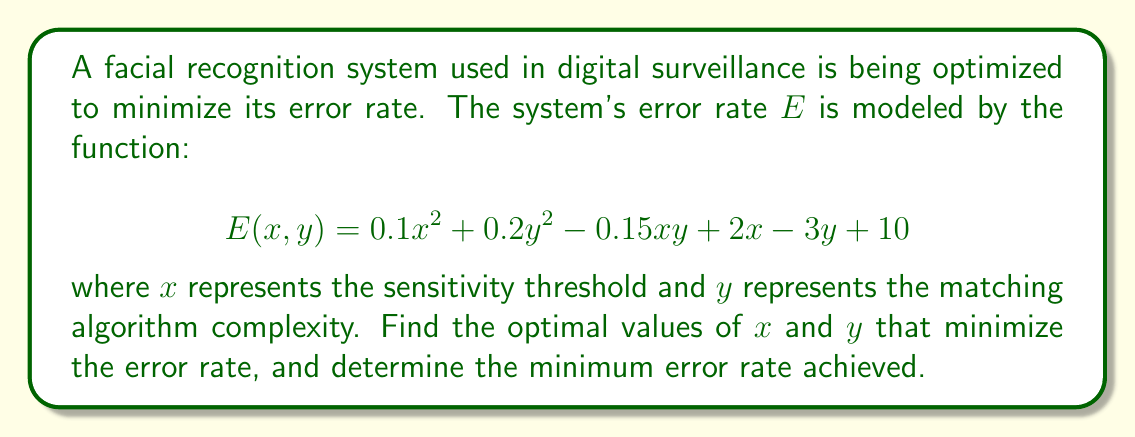Can you solve this math problem? To find the minimum error rate, we need to determine the values of $x$ and $y$ that minimize the function $E(x, y)$. This is an optimization problem that can be solved using partial derivatives.

1. Calculate the partial derivatives of $E$ with respect to $x$ and $y$:

   $$\frac{\partial E}{\partial x} = 0.2x - 0.15y + 2$$
   $$\frac{\partial E}{\partial y} = 0.4y - 0.15x - 3$$

2. Set both partial derivatives to zero to find the critical points:

   $$0.2x - 0.15y + 2 = 0 \quad (1)$$
   $$0.4y - 0.15x - 3 = 0 \quad (2)$$

3. Solve the system of equations:
   Multiply equation (1) by 2 and equation (2) by 4:

   $$0.4x - 0.3y + 4 = 0 \quad (3)$$
   $$1.6y - 0.6x - 12 = 0 \quad (4)$$

   Add equations (3) and (4):

   $$1.3y - 0.2x - 8 = 0 \quad (5)$$

   Substitute (5) into (1):

   $$0.2x - 0.15(\frac{0.2x - 8}{1.3}) + 2 = 0$$
   $$0.2x - 0.023x + 0.923 + 2 = 0$$
   $$0.177x = -2.923$$
   $$x \approx -16.51$$

   Substitute this $x$ value back into (5) to find $y$:

   $$1.3y - 0.2(-16.51) - 8 = 0$$
   $$1.3y + 3.302 - 8 = 0$$
   $$1.3y = 4.698$$
   $$y \approx 3.61$$

4. Verify that this critical point is a minimum by checking the second partial derivatives:

   $$\frac{\partial^2 E}{\partial x^2} = 0.2 > 0$$
   $$\frac{\partial^2 E}{\partial y^2} = 0.4 > 0$$
   $$\frac{\partial^2 E}{\partial x \partial y} = -0.15$$

   The determinant of the Hessian matrix is:
   $$0.2 \cdot 0.4 - (-0.15)^2 = 0.0575 > 0$$

   Since both second partial derivatives are positive and the determinant of the Hessian is positive, this critical point is a local minimum.

5. Calculate the minimum error rate by substituting the optimal $x$ and $y$ values into the original function:

   $$E(-16.51, 3.61) = 0.1(-16.51)^2 + 0.2(3.61)^2 - 0.15(-16.51)(3.61) + 2(-16.51) - 3(3.61) + 10$$
   $$\approx 27.23 + 2.61 + 8.94 - 33.02 - 10.83 + 10$$
   $$\approx 4.93$$
Answer: The optimal values are $x \approx -16.51$ and $y \approx 3.61$, resulting in a minimum error rate of approximately 4.93%. 